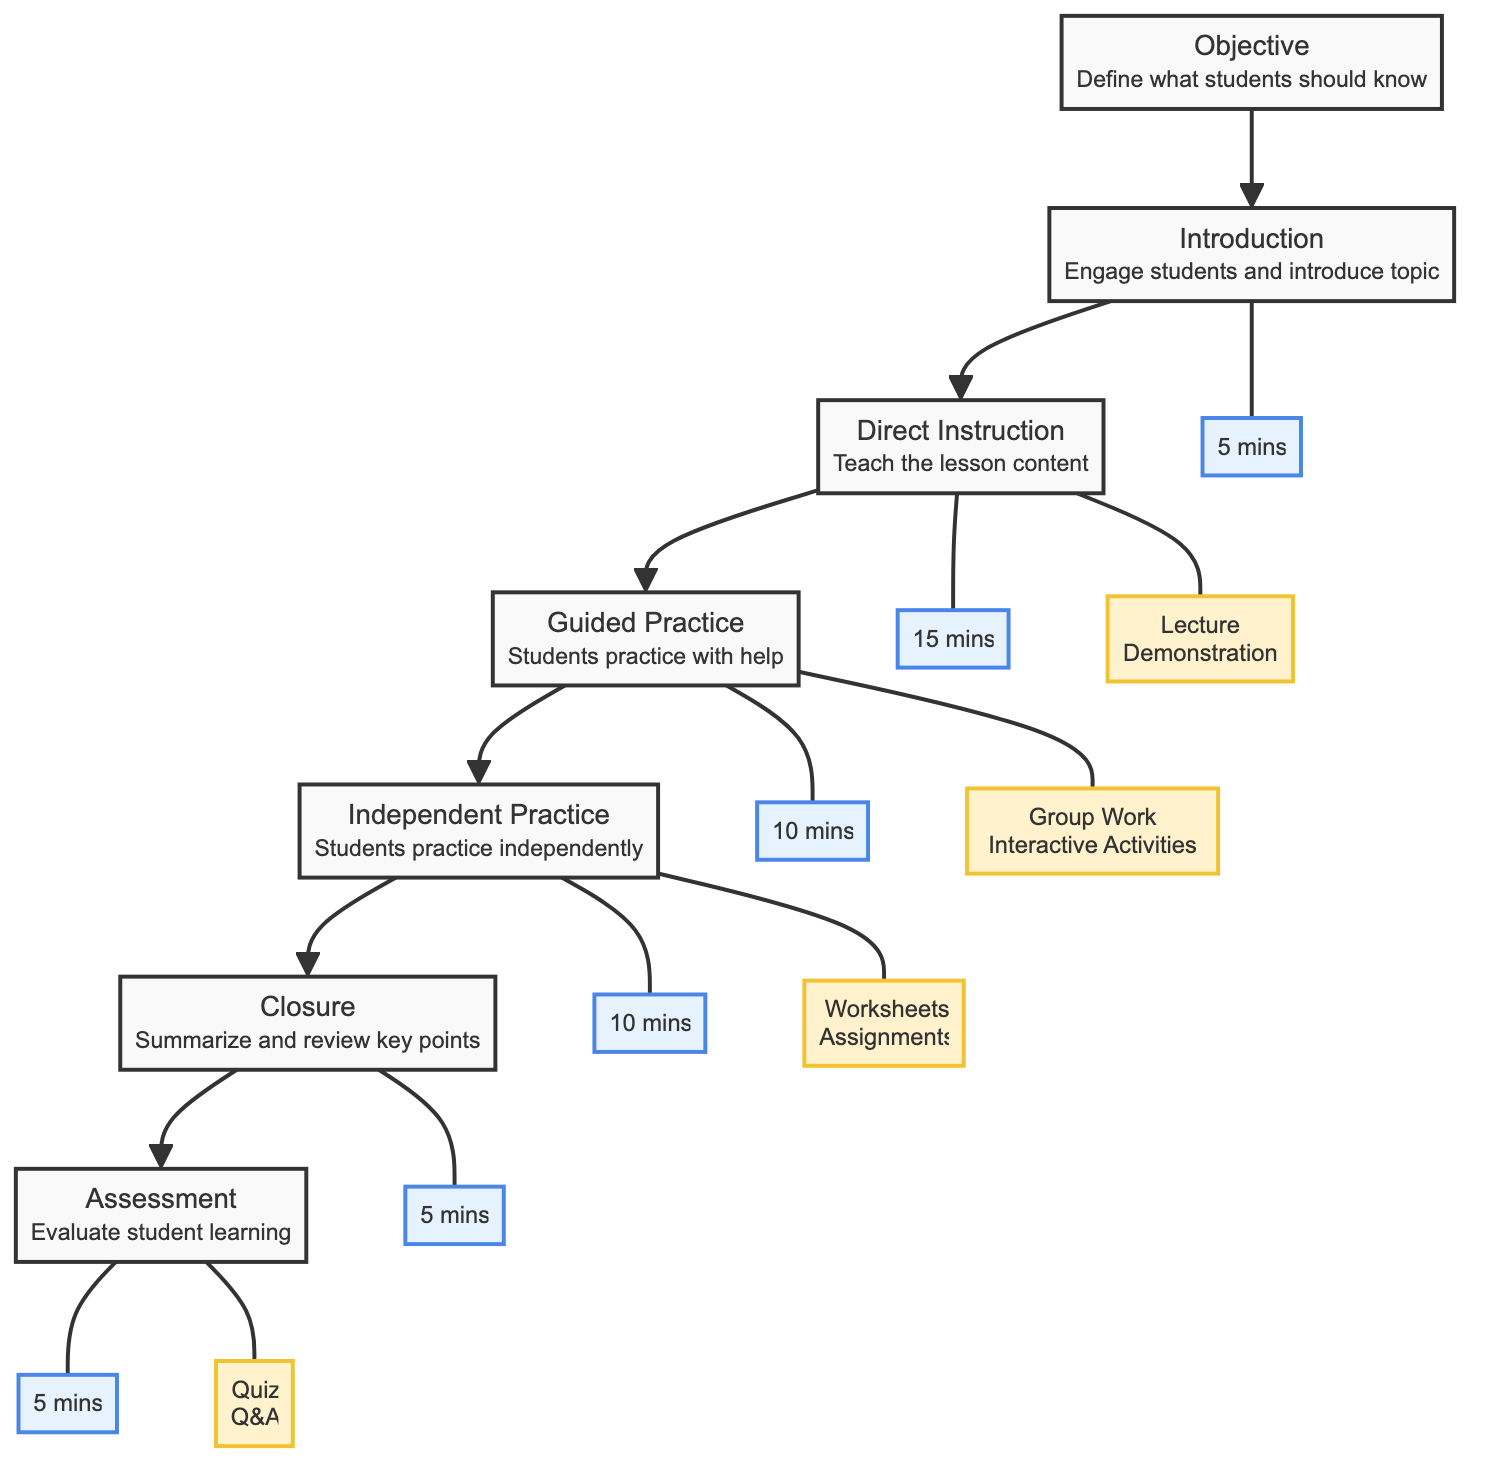What is the total number of activities listed in the diagram? There are seven distinct activities outlined in the diagram, labeled from Objective to Assessment. Counting these activities gives a total of 7.
Answer: 7 What is the time allocated for Direct Instruction? The diagram shows that Direct Instruction has a time allocation of 15 minutes as indicated in the time box connected to the Direct Instruction node.
Answer: 15 mins Which teaching method is associated with Independent Practice? The method associated with Independent Practice is "Worksheets" and "Assignments," as shown by the method box connected to the Independent Practice node.
Answer: Worksheets, Assignments What is the sequence of activities beginning from Introduction to Assessment? The sequence followed is: Introduction, Direct Instruction, Guided Practice, Independent Practice, Closure, and finally Assessment. These activities are connected in a linear fashion from the Introduction to the Assessment node.
Answer: Introduction, Direct Instruction, Guided Practice, Independent Practice, Closure, Assessment How many minutes in total are dedicated to Closure and Assessment combined? Closure is allocated 5 minutes and Assessment is allocated another 5 minutes. Adding these two time allocations gives a total of 10 minutes for both activities.
Answer: 10 mins Which activity comes immediately after Guided Practice? The activity that comes directly after Guided Practice is Independent Practice as depicted by the diagram’s flow indicating the next step in the lesson plan.
Answer: Independent Practice What type of method is used during Guided Practice? The method utilized during Guided Practice is "Group Work" and "Interactive Activities," which is specified in the method box connected to the Guided Practice node.
Answer: Group Work, Interactive Activities What is the purpose of the Closure activity? The purpose of the Closure activity, as stated in the diagram, is to summarize and review key points from the lesson, serving as an important wrap-up to the instructional sequence.
Answer: Summarize and review key points 